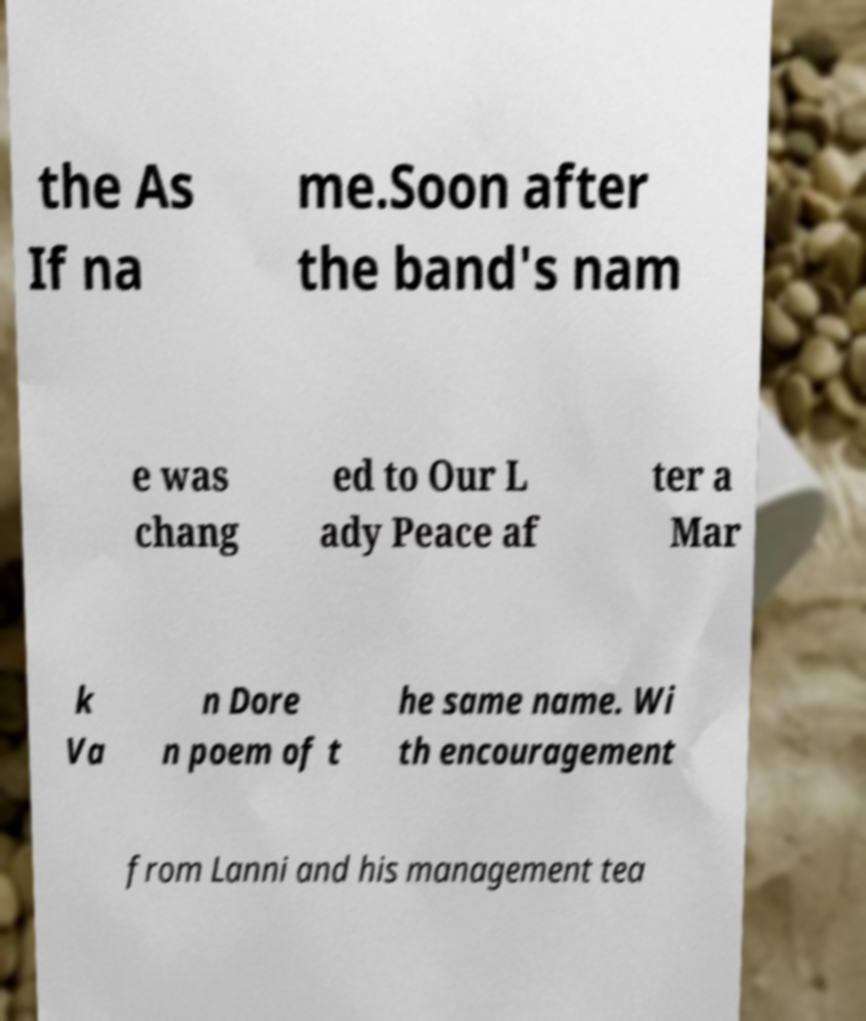Please read and relay the text visible in this image. What does it say? the As If na me.Soon after the band's nam e was chang ed to Our L ady Peace af ter a Mar k Va n Dore n poem of t he same name. Wi th encouragement from Lanni and his management tea 